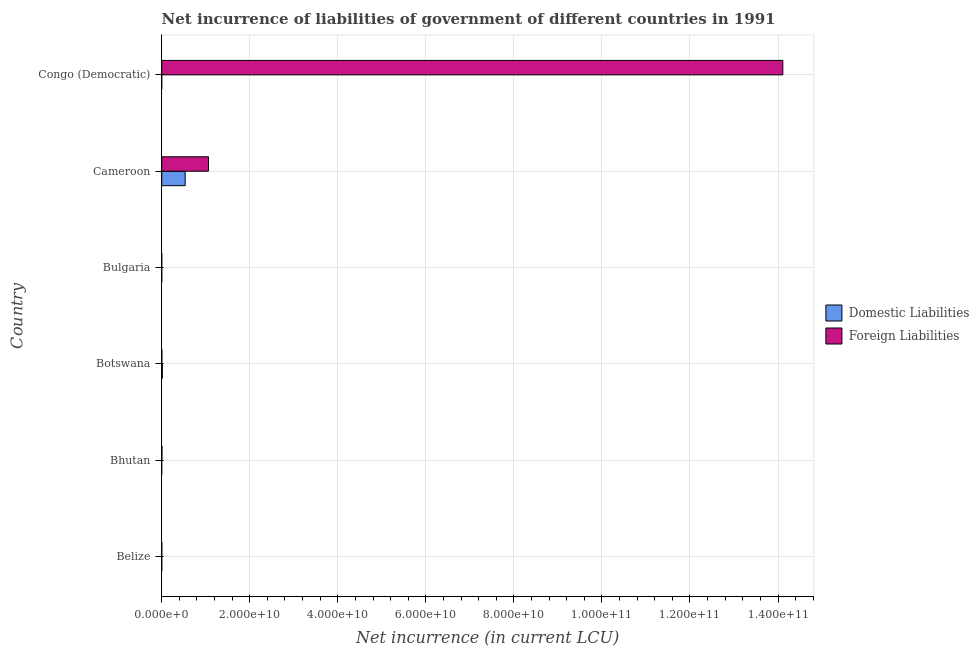How many different coloured bars are there?
Provide a short and direct response. 2. Are the number of bars per tick equal to the number of legend labels?
Give a very brief answer. No. How many bars are there on the 2nd tick from the top?
Keep it short and to the point. 2. What is the label of the 2nd group of bars from the top?
Keep it short and to the point. Cameroon. What is the net incurrence of foreign liabilities in Bulgaria?
Offer a terse response. 3.76e+06. Across all countries, what is the maximum net incurrence of domestic liabilities?
Ensure brevity in your answer.  5.33e+09. Across all countries, what is the minimum net incurrence of domestic liabilities?
Your answer should be compact. 0. In which country was the net incurrence of foreign liabilities maximum?
Give a very brief answer. Congo (Democratic). What is the total net incurrence of domestic liabilities in the graph?
Make the answer very short. 5.48e+09. What is the difference between the net incurrence of domestic liabilities in Belize and that in Cameroon?
Make the answer very short. -5.33e+09. What is the difference between the net incurrence of foreign liabilities in Cameroon and the net incurrence of domestic liabilities in Congo (Democratic)?
Provide a short and direct response. 1.06e+1. What is the average net incurrence of domestic liabilities per country?
Offer a very short reply. 9.14e+08. What is the difference between the net incurrence of domestic liabilities and net incurrence of foreign liabilities in Belize?
Your answer should be compact. -1.56e+07. In how many countries, is the net incurrence of foreign liabilities greater than 4000000000 LCU?
Your answer should be very brief. 2. What is the ratio of the net incurrence of foreign liabilities in Bhutan to that in Bulgaria?
Your answer should be compact. 14.15. What is the difference between the highest and the second highest net incurrence of foreign liabilities?
Give a very brief answer. 1.30e+11. What is the difference between the highest and the lowest net incurrence of domestic liabilities?
Make the answer very short. 5.33e+09. In how many countries, is the net incurrence of foreign liabilities greater than the average net incurrence of foreign liabilities taken over all countries?
Provide a short and direct response. 1. Are all the bars in the graph horizontal?
Give a very brief answer. Yes. How many countries are there in the graph?
Make the answer very short. 6. What is the difference between two consecutive major ticks on the X-axis?
Offer a terse response. 2.00e+1. Does the graph contain grids?
Provide a short and direct response. Yes. Where does the legend appear in the graph?
Give a very brief answer. Center right. How many legend labels are there?
Offer a terse response. 2. What is the title of the graph?
Provide a succinct answer. Net incurrence of liabilities of government of different countries in 1991. What is the label or title of the X-axis?
Offer a very short reply. Net incurrence (in current LCU). What is the label or title of the Y-axis?
Offer a terse response. Country. What is the Net incurrence (in current LCU) in Domestic Liabilities in Belize?
Ensure brevity in your answer.  3.82e+06. What is the Net incurrence (in current LCU) of Foreign Liabilities in Belize?
Your answer should be very brief. 1.94e+07. What is the Net incurrence (in current LCU) of Foreign Liabilities in Bhutan?
Your response must be concise. 5.32e+07. What is the Net incurrence (in current LCU) in Domestic Liabilities in Botswana?
Offer a very short reply. 1.40e+08. What is the Net incurrence (in current LCU) in Foreign Liabilities in Botswana?
Your answer should be very brief. 3.60e+07. What is the Net incurrence (in current LCU) in Domestic Liabilities in Bulgaria?
Keep it short and to the point. 7.47e+06. What is the Net incurrence (in current LCU) in Foreign Liabilities in Bulgaria?
Offer a terse response. 3.76e+06. What is the Net incurrence (in current LCU) of Domestic Liabilities in Cameroon?
Offer a terse response. 5.33e+09. What is the Net incurrence (in current LCU) in Foreign Liabilities in Cameroon?
Provide a short and direct response. 1.06e+1. What is the Net incurrence (in current LCU) in Domestic Liabilities in Congo (Democratic)?
Offer a terse response. 67.82. What is the Net incurrence (in current LCU) in Foreign Liabilities in Congo (Democratic)?
Provide a succinct answer. 1.41e+11. Across all countries, what is the maximum Net incurrence (in current LCU) of Domestic Liabilities?
Your answer should be compact. 5.33e+09. Across all countries, what is the maximum Net incurrence (in current LCU) of Foreign Liabilities?
Your answer should be very brief. 1.41e+11. Across all countries, what is the minimum Net incurrence (in current LCU) in Domestic Liabilities?
Provide a succinct answer. 0. Across all countries, what is the minimum Net incurrence (in current LCU) of Foreign Liabilities?
Offer a very short reply. 3.76e+06. What is the total Net incurrence (in current LCU) of Domestic Liabilities in the graph?
Provide a succinct answer. 5.48e+09. What is the total Net incurrence (in current LCU) in Foreign Liabilities in the graph?
Offer a terse response. 1.52e+11. What is the difference between the Net incurrence (in current LCU) in Foreign Liabilities in Belize and that in Bhutan?
Your response must be concise. -3.38e+07. What is the difference between the Net incurrence (in current LCU) of Domestic Liabilities in Belize and that in Botswana?
Offer a terse response. -1.37e+08. What is the difference between the Net incurrence (in current LCU) in Foreign Liabilities in Belize and that in Botswana?
Give a very brief answer. -1.66e+07. What is the difference between the Net incurrence (in current LCU) in Domestic Liabilities in Belize and that in Bulgaria?
Offer a very short reply. -3.66e+06. What is the difference between the Net incurrence (in current LCU) in Foreign Liabilities in Belize and that in Bulgaria?
Keep it short and to the point. 1.56e+07. What is the difference between the Net incurrence (in current LCU) in Domestic Liabilities in Belize and that in Cameroon?
Provide a short and direct response. -5.33e+09. What is the difference between the Net incurrence (in current LCU) of Foreign Liabilities in Belize and that in Cameroon?
Offer a very short reply. -1.06e+1. What is the difference between the Net incurrence (in current LCU) of Domestic Liabilities in Belize and that in Congo (Democratic)?
Give a very brief answer. 3.82e+06. What is the difference between the Net incurrence (in current LCU) in Foreign Liabilities in Belize and that in Congo (Democratic)?
Offer a terse response. -1.41e+11. What is the difference between the Net incurrence (in current LCU) in Foreign Liabilities in Bhutan and that in Botswana?
Your response must be concise. 1.72e+07. What is the difference between the Net incurrence (in current LCU) of Foreign Liabilities in Bhutan and that in Bulgaria?
Offer a terse response. 4.94e+07. What is the difference between the Net incurrence (in current LCU) of Foreign Liabilities in Bhutan and that in Cameroon?
Your response must be concise. -1.06e+1. What is the difference between the Net incurrence (in current LCU) in Foreign Liabilities in Bhutan and that in Congo (Democratic)?
Your answer should be very brief. -1.41e+11. What is the difference between the Net incurrence (in current LCU) of Domestic Liabilities in Botswana and that in Bulgaria?
Give a very brief answer. 1.33e+08. What is the difference between the Net incurrence (in current LCU) in Foreign Liabilities in Botswana and that in Bulgaria?
Provide a short and direct response. 3.22e+07. What is the difference between the Net incurrence (in current LCU) of Domestic Liabilities in Botswana and that in Cameroon?
Provide a short and direct response. -5.19e+09. What is the difference between the Net incurrence (in current LCU) in Foreign Liabilities in Botswana and that in Cameroon?
Keep it short and to the point. -1.06e+1. What is the difference between the Net incurrence (in current LCU) of Domestic Liabilities in Botswana and that in Congo (Democratic)?
Ensure brevity in your answer.  1.40e+08. What is the difference between the Net incurrence (in current LCU) of Foreign Liabilities in Botswana and that in Congo (Democratic)?
Keep it short and to the point. -1.41e+11. What is the difference between the Net incurrence (in current LCU) in Domestic Liabilities in Bulgaria and that in Cameroon?
Your answer should be compact. -5.32e+09. What is the difference between the Net incurrence (in current LCU) of Foreign Liabilities in Bulgaria and that in Cameroon?
Your answer should be compact. -1.06e+1. What is the difference between the Net incurrence (in current LCU) of Domestic Liabilities in Bulgaria and that in Congo (Democratic)?
Offer a terse response. 7.47e+06. What is the difference between the Net incurrence (in current LCU) in Foreign Liabilities in Bulgaria and that in Congo (Democratic)?
Give a very brief answer. -1.41e+11. What is the difference between the Net incurrence (in current LCU) of Domestic Liabilities in Cameroon and that in Congo (Democratic)?
Provide a succinct answer. 5.33e+09. What is the difference between the Net incurrence (in current LCU) in Foreign Liabilities in Cameroon and that in Congo (Democratic)?
Provide a succinct answer. -1.30e+11. What is the difference between the Net incurrence (in current LCU) of Domestic Liabilities in Belize and the Net incurrence (in current LCU) of Foreign Liabilities in Bhutan?
Offer a very short reply. -4.94e+07. What is the difference between the Net incurrence (in current LCU) of Domestic Liabilities in Belize and the Net incurrence (in current LCU) of Foreign Liabilities in Botswana?
Your answer should be compact. -3.22e+07. What is the difference between the Net incurrence (in current LCU) in Domestic Liabilities in Belize and the Net incurrence (in current LCU) in Foreign Liabilities in Bulgaria?
Provide a short and direct response. 5.80e+04. What is the difference between the Net incurrence (in current LCU) in Domestic Liabilities in Belize and the Net incurrence (in current LCU) in Foreign Liabilities in Cameroon?
Your answer should be very brief. -1.06e+1. What is the difference between the Net incurrence (in current LCU) in Domestic Liabilities in Belize and the Net incurrence (in current LCU) in Foreign Liabilities in Congo (Democratic)?
Make the answer very short. -1.41e+11. What is the difference between the Net incurrence (in current LCU) in Domestic Liabilities in Botswana and the Net incurrence (in current LCU) in Foreign Liabilities in Bulgaria?
Provide a short and direct response. 1.37e+08. What is the difference between the Net incurrence (in current LCU) of Domestic Liabilities in Botswana and the Net incurrence (in current LCU) of Foreign Liabilities in Cameroon?
Provide a short and direct response. -1.05e+1. What is the difference between the Net incurrence (in current LCU) in Domestic Liabilities in Botswana and the Net incurrence (in current LCU) in Foreign Liabilities in Congo (Democratic)?
Give a very brief answer. -1.41e+11. What is the difference between the Net incurrence (in current LCU) of Domestic Liabilities in Bulgaria and the Net incurrence (in current LCU) of Foreign Liabilities in Cameroon?
Keep it short and to the point. -1.06e+1. What is the difference between the Net incurrence (in current LCU) in Domestic Liabilities in Bulgaria and the Net incurrence (in current LCU) in Foreign Liabilities in Congo (Democratic)?
Offer a terse response. -1.41e+11. What is the difference between the Net incurrence (in current LCU) of Domestic Liabilities in Cameroon and the Net incurrence (in current LCU) of Foreign Liabilities in Congo (Democratic)?
Your response must be concise. -1.36e+11. What is the average Net incurrence (in current LCU) of Domestic Liabilities per country?
Offer a very short reply. 9.14e+08. What is the average Net incurrence (in current LCU) in Foreign Liabilities per country?
Your answer should be compact. 2.53e+1. What is the difference between the Net incurrence (in current LCU) in Domestic Liabilities and Net incurrence (in current LCU) in Foreign Liabilities in Belize?
Give a very brief answer. -1.56e+07. What is the difference between the Net incurrence (in current LCU) in Domestic Liabilities and Net incurrence (in current LCU) in Foreign Liabilities in Botswana?
Give a very brief answer. 1.04e+08. What is the difference between the Net incurrence (in current LCU) of Domestic Liabilities and Net incurrence (in current LCU) of Foreign Liabilities in Bulgaria?
Your response must be concise. 3.71e+06. What is the difference between the Net incurrence (in current LCU) in Domestic Liabilities and Net incurrence (in current LCU) in Foreign Liabilities in Cameroon?
Provide a succinct answer. -5.29e+09. What is the difference between the Net incurrence (in current LCU) of Domestic Liabilities and Net incurrence (in current LCU) of Foreign Liabilities in Congo (Democratic)?
Ensure brevity in your answer.  -1.41e+11. What is the ratio of the Net incurrence (in current LCU) in Foreign Liabilities in Belize to that in Bhutan?
Provide a succinct answer. 0.36. What is the ratio of the Net incurrence (in current LCU) of Domestic Liabilities in Belize to that in Botswana?
Offer a very short reply. 0.03. What is the ratio of the Net incurrence (in current LCU) of Foreign Liabilities in Belize to that in Botswana?
Your response must be concise. 0.54. What is the ratio of the Net incurrence (in current LCU) of Domestic Liabilities in Belize to that in Bulgaria?
Offer a very short reply. 0.51. What is the ratio of the Net incurrence (in current LCU) in Foreign Liabilities in Belize to that in Bulgaria?
Give a very brief answer. 5.16. What is the ratio of the Net incurrence (in current LCU) of Domestic Liabilities in Belize to that in Cameroon?
Your answer should be very brief. 0. What is the ratio of the Net incurrence (in current LCU) of Foreign Liabilities in Belize to that in Cameroon?
Ensure brevity in your answer.  0. What is the ratio of the Net incurrence (in current LCU) of Domestic Liabilities in Belize to that in Congo (Democratic)?
Offer a terse response. 5.63e+04. What is the ratio of the Net incurrence (in current LCU) of Foreign Liabilities in Bhutan to that in Botswana?
Keep it short and to the point. 1.48. What is the ratio of the Net incurrence (in current LCU) in Foreign Liabilities in Bhutan to that in Bulgaria?
Offer a very short reply. 14.15. What is the ratio of the Net incurrence (in current LCU) in Foreign Liabilities in Bhutan to that in Cameroon?
Provide a succinct answer. 0.01. What is the ratio of the Net incurrence (in current LCU) in Domestic Liabilities in Botswana to that in Bulgaria?
Your answer should be compact. 18.79. What is the ratio of the Net incurrence (in current LCU) in Foreign Liabilities in Botswana to that in Bulgaria?
Ensure brevity in your answer.  9.57. What is the ratio of the Net incurrence (in current LCU) of Domestic Liabilities in Botswana to that in Cameroon?
Your response must be concise. 0.03. What is the ratio of the Net incurrence (in current LCU) in Foreign Liabilities in Botswana to that in Cameroon?
Give a very brief answer. 0. What is the ratio of the Net incurrence (in current LCU) in Domestic Liabilities in Botswana to that in Congo (Democratic)?
Your response must be concise. 2.07e+06. What is the ratio of the Net incurrence (in current LCU) in Foreign Liabilities in Botswana to that in Congo (Democratic)?
Your response must be concise. 0. What is the ratio of the Net incurrence (in current LCU) in Domestic Liabilities in Bulgaria to that in Cameroon?
Your answer should be very brief. 0. What is the ratio of the Net incurrence (in current LCU) in Foreign Liabilities in Bulgaria to that in Cameroon?
Provide a succinct answer. 0. What is the ratio of the Net incurrence (in current LCU) of Domestic Liabilities in Bulgaria to that in Congo (Democratic)?
Provide a succinct answer. 1.10e+05. What is the ratio of the Net incurrence (in current LCU) in Domestic Liabilities in Cameroon to that in Congo (Democratic)?
Provide a succinct answer. 7.86e+07. What is the ratio of the Net incurrence (in current LCU) in Foreign Liabilities in Cameroon to that in Congo (Democratic)?
Ensure brevity in your answer.  0.08. What is the difference between the highest and the second highest Net incurrence (in current LCU) in Domestic Liabilities?
Your answer should be compact. 5.19e+09. What is the difference between the highest and the second highest Net incurrence (in current LCU) in Foreign Liabilities?
Provide a succinct answer. 1.30e+11. What is the difference between the highest and the lowest Net incurrence (in current LCU) in Domestic Liabilities?
Give a very brief answer. 5.33e+09. What is the difference between the highest and the lowest Net incurrence (in current LCU) in Foreign Liabilities?
Ensure brevity in your answer.  1.41e+11. 